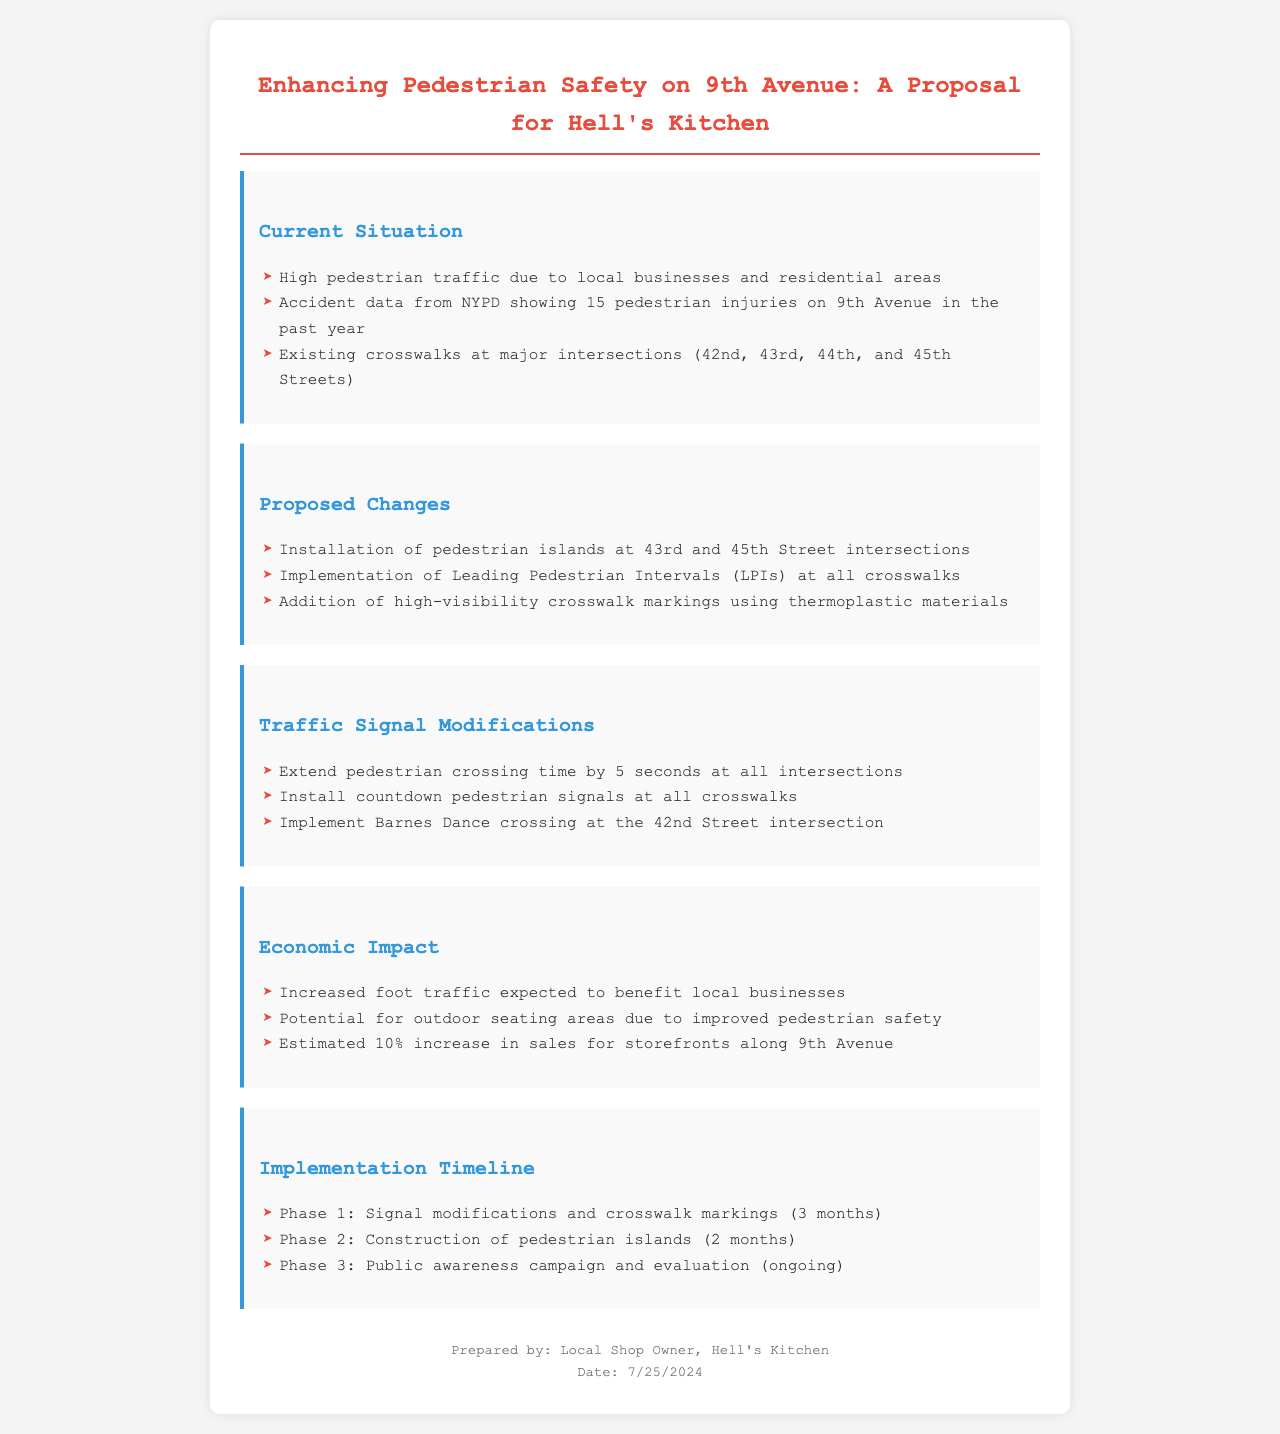What is the total number of pedestrian injuries reported in the past year? The total number of pedestrian injuries is mentioned as 15 in the document.
Answer: 15 What are the proposed changes for crosswalks? Proposed changes for crosswalks are detailed in the section on proposed changes, including pedestrian islands and LPI implementation.
Answer: Pedestrian islands, Leading Pedestrian Intervals What is the expected percentage increase in sales for storefronts along 9th Avenue? The expected percentage increase in sales is stated in the Economic Impact section of the document.
Answer: 10% What is the duration of Phase 1 of the implementation timeline? Phase 1 specifically mentions that it will take 3 months to complete based on the timeline provided.
Answer: 3 months What type of pedestrian signals will be installed at all crosswalks? The type of pedestrian signals to be installed is explicitly mentioned in the Traffic Signal Modifications section.
Answer: Countdown pedestrian signals What intersections will have pedestrian islands installed? The specific intersections mentioned for pedestrian island installation are detailed in the proposed changes section of the document.
Answer: 43rd and 45th Streets What kind of campaign will occur in Phase 3? The document outlines that there will be a public awareness campaign during Phase 3 of the implementation timeline.
Answer: Public awareness campaign What is one potential benefit of increased pedestrian safety for local businesses? The document expresses that improved pedestrian safety can lead to specific benefits for local businesses, noted in the economic impact section.
Answer: Outdoor seating areas 